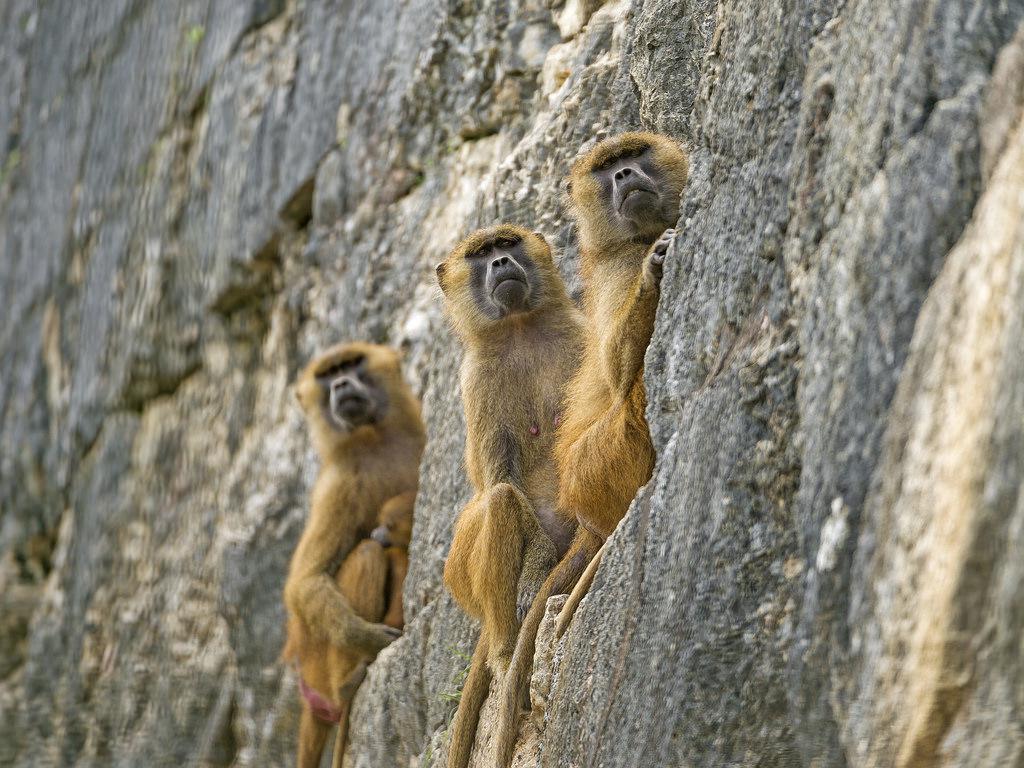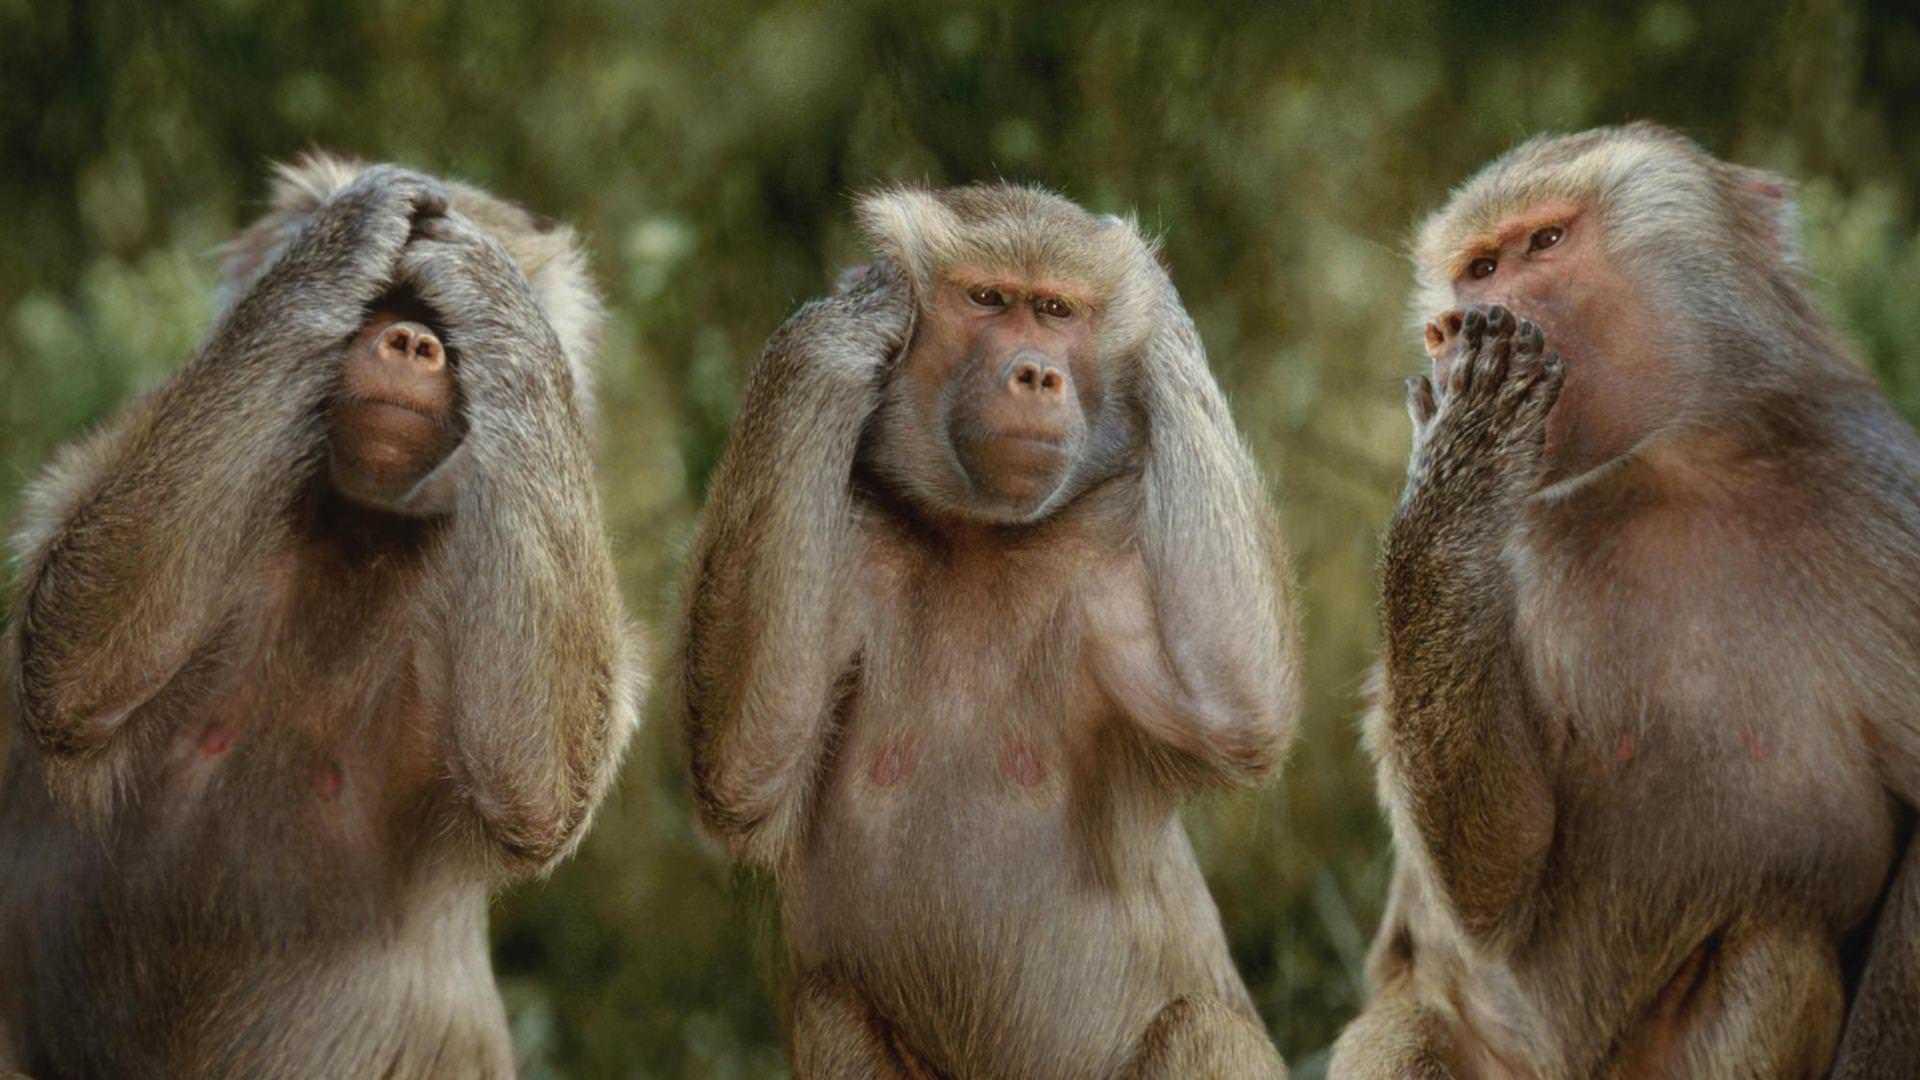The first image is the image on the left, the second image is the image on the right. Assess this claim about the two images: "The combined images contain six baboons.". Correct or not? Answer yes or no. Yes. The first image is the image on the left, the second image is the image on the right. Assess this claim about the two images: "The left image contains no more than two monkeys.". Correct or not? Answer yes or no. No. 